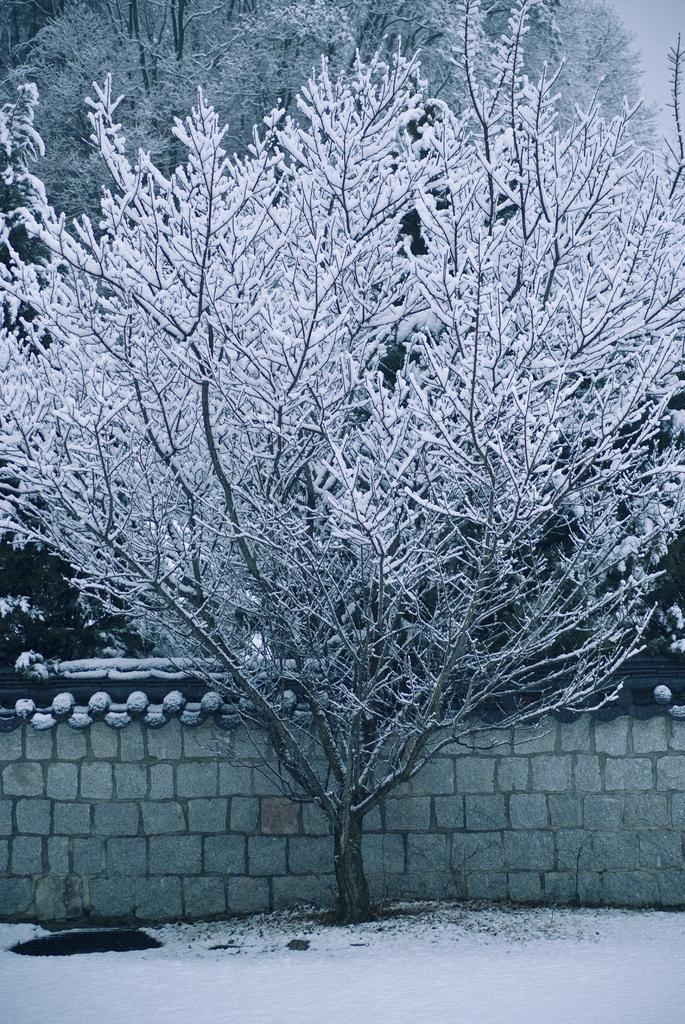What is the main structure in the center of the image? There is a wall in the center of the image. What type of weather condition is depicted in the image? Snow is present on the surface at the bottom of the image. What can be seen in the background of the image? There are trees in the background of the image. How many houses can be seen in the image? There are no houses visible in the image; it primarily features a wall, snow, and trees. Are there any geese present in the image? There are no geese depicted in the image. 